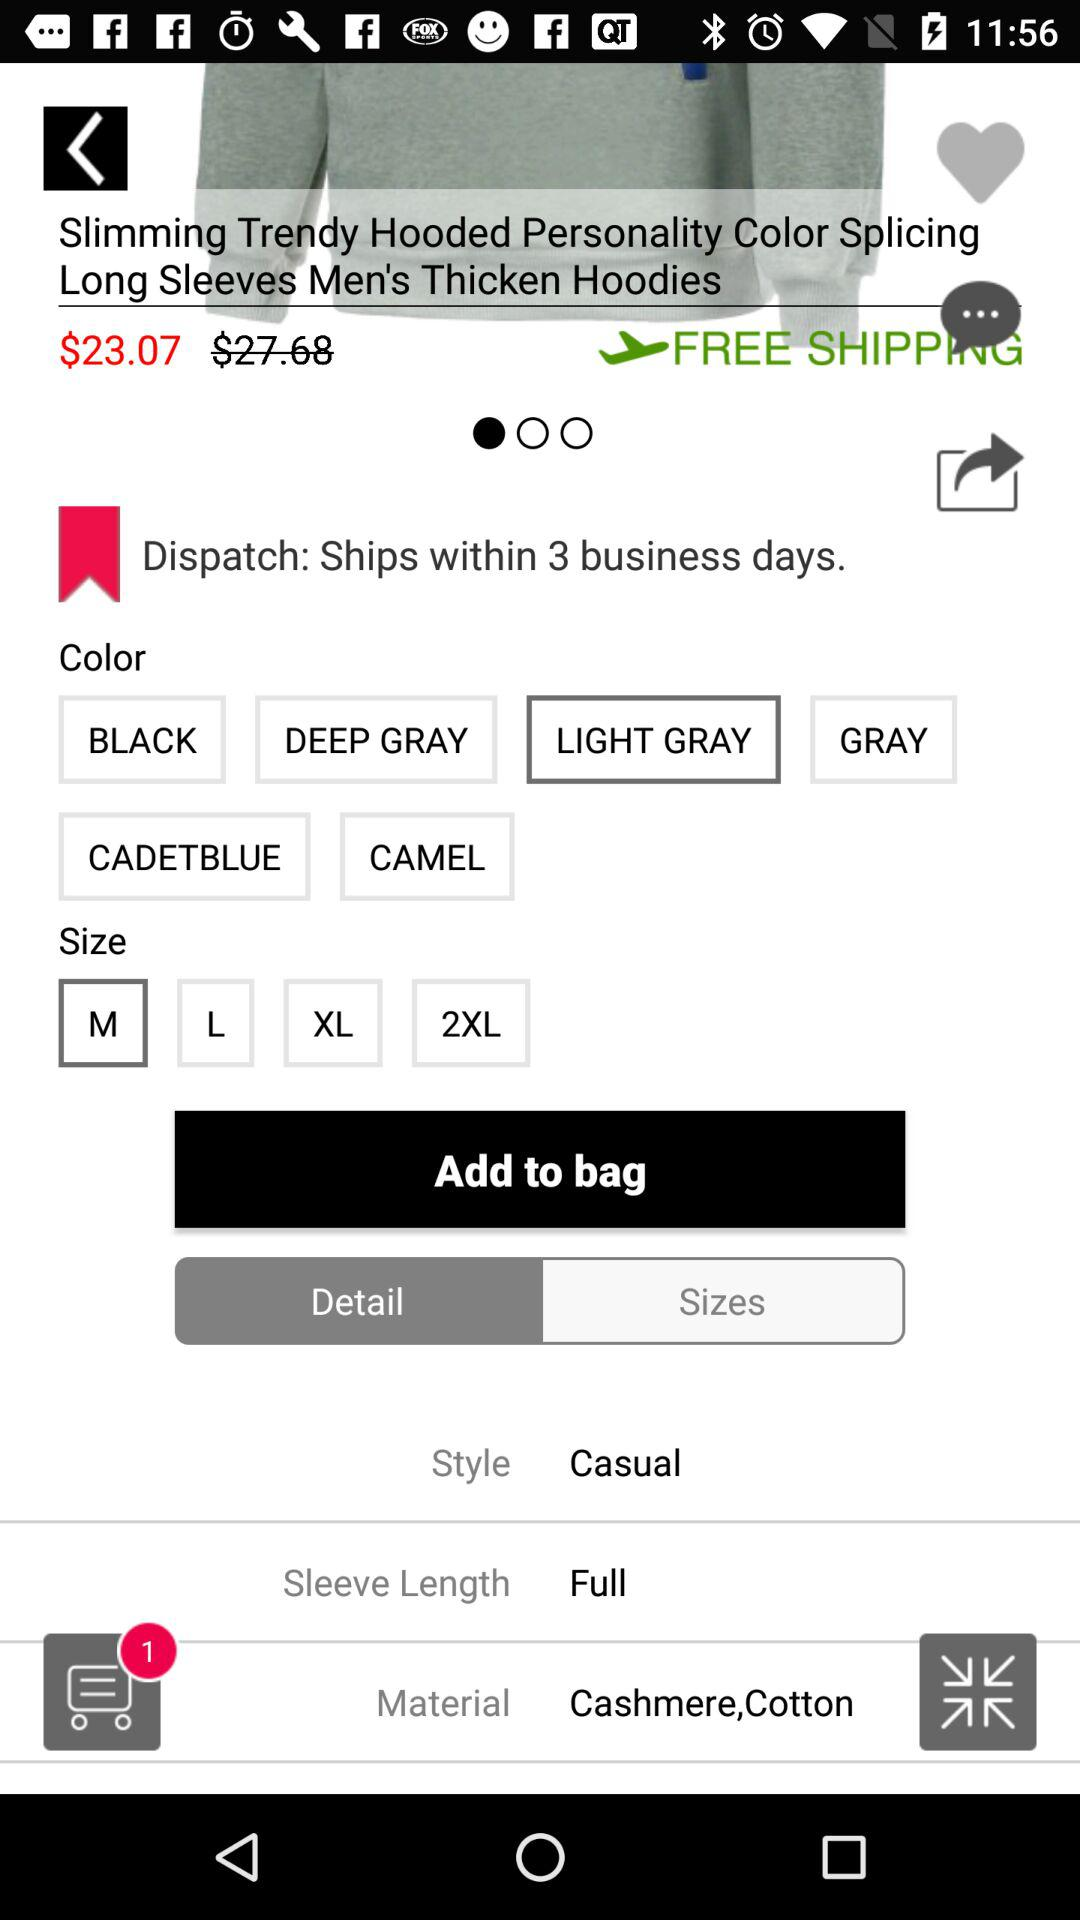What is the type of style? The type of style is casual. 